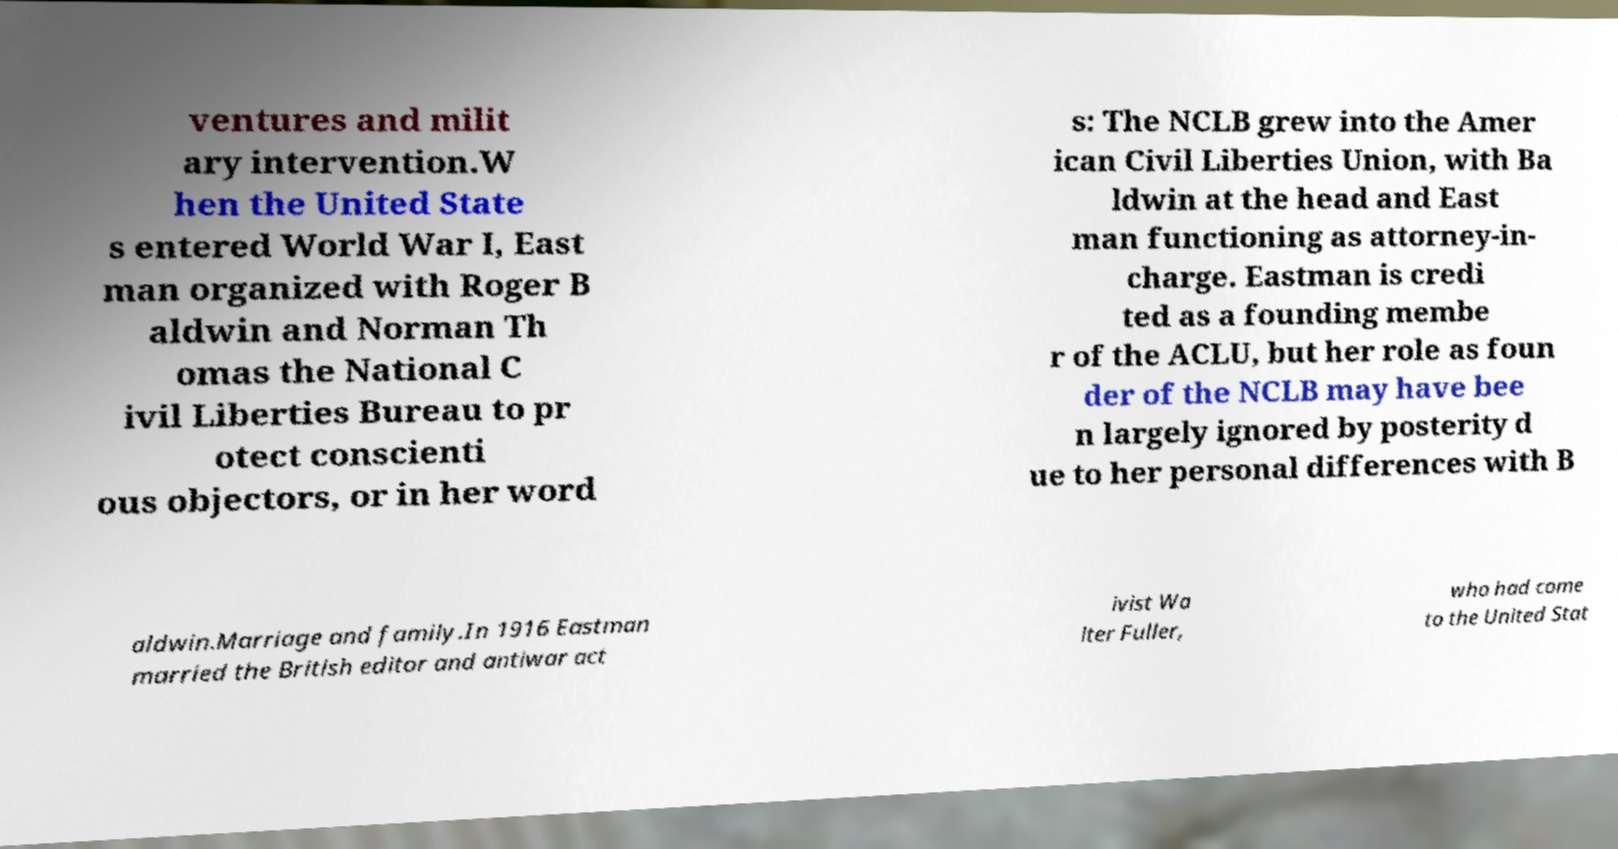Please identify and transcribe the text found in this image. ventures and milit ary intervention.W hen the United State s entered World War I, East man organized with Roger B aldwin and Norman Th omas the National C ivil Liberties Bureau to pr otect conscienti ous objectors, or in her word s: The NCLB grew into the Amer ican Civil Liberties Union, with Ba ldwin at the head and East man functioning as attorney-in- charge. Eastman is credi ted as a founding membe r of the ACLU, but her role as foun der of the NCLB may have bee n largely ignored by posterity d ue to her personal differences with B aldwin.Marriage and family.In 1916 Eastman married the British editor and antiwar act ivist Wa lter Fuller, who had come to the United Stat 